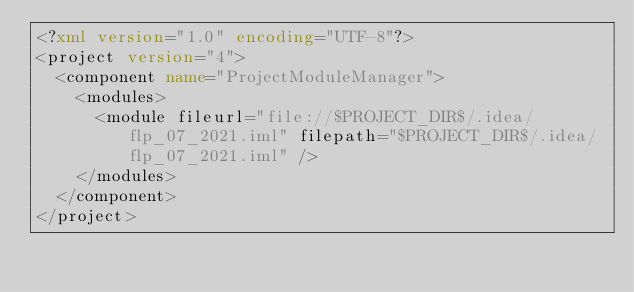<code> <loc_0><loc_0><loc_500><loc_500><_XML_><?xml version="1.0" encoding="UTF-8"?>
<project version="4">
  <component name="ProjectModuleManager">
    <modules>
      <module fileurl="file://$PROJECT_DIR$/.idea/flp_07_2021.iml" filepath="$PROJECT_DIR$/.idea/flp_07_2021.iml" />
    </modules>
  </component>
</project></code> 